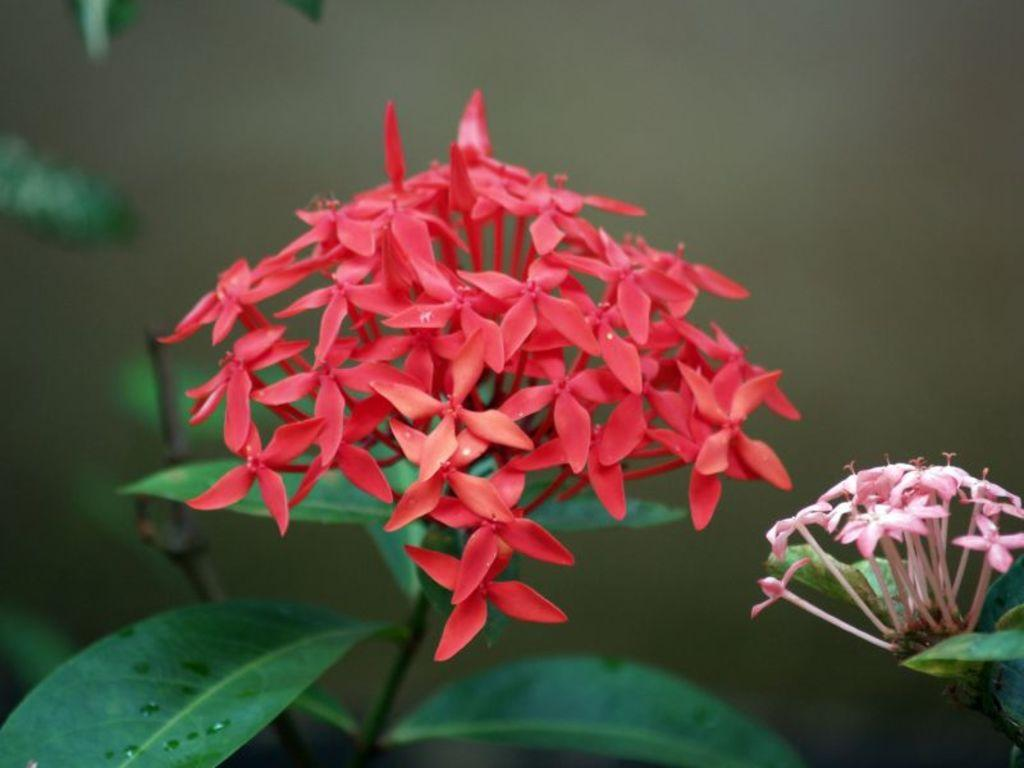What type of plants are in the image? There are flowers in the image. What colors can be seen on the flowers? The flowers have two different colors: pink and red. What else can be seen in the background of the image? There are leaves visible in the background of the image. What type of ice can be seen melting near the flowers in the image? There is no ice present in the image; it features flowers with pink and red colors and leaves in the background. 